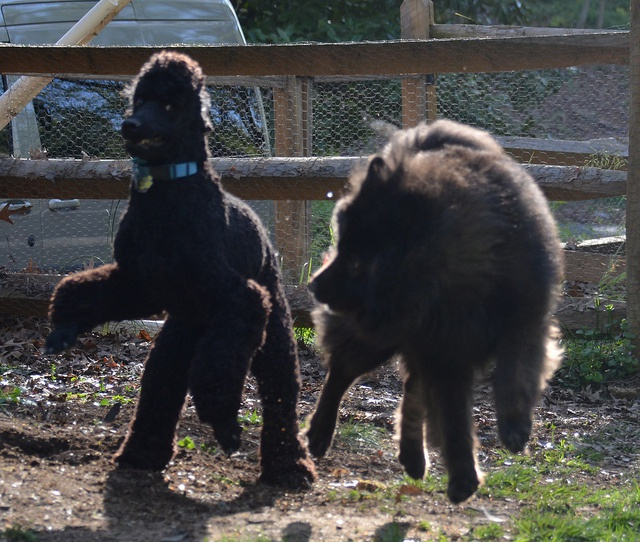Describe the objects in this image and their specific colors. I can see dog in darkgray, black, and gray tones, dog in darkgray, black, and gray tones, and truck in darkgray, gray, black, and blue tones in this image. 